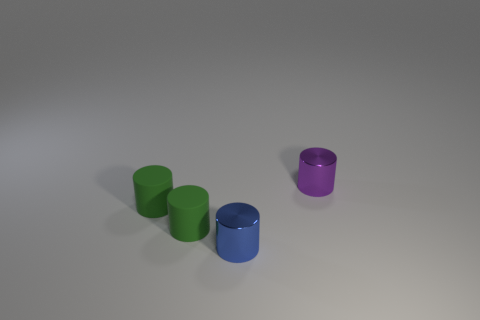There is a blue object that is the same shape as the small purple metal object; what is it made of?
Ensure brevity in your answer.  Metal. Is there anything else that has the same size as the purple metal cylinder?
Your response must be concise. Yes. There is a metal object that is to the left of the tiny purple metal cylinder; is it the same shape as the small metallic object that is on the right side of the blue metal object?
Provide a short and direct response. Yes. Are there fewer green objects on the right side of the blue cylinder than objects behind the tiny purple object?
Make the answer very short. No. How many other things are the same shape as the blue shiny object?
Your answer should be very brief. 3. There is another thing that is made of the same material as the small purple object; what shape is it?
Your response must be concise. Cylinder. Is the material of the blue cylinder left of the tiny purple shiny cylinder the same as the small purple thing?
Provide a succinct answer. Yes. Are there fewer green rubber cylinders that are behind the tiny purple metallic object than red blocks?
Your answer should be compact. No. Is there a big purple object that has the same material as the purple cylinder?
Ensure brevity in your answer.  No. Do the purple shiny cylinder and the metal cylinder to the left of the purple object have the same size?
Your answer should be compact. Yes. 